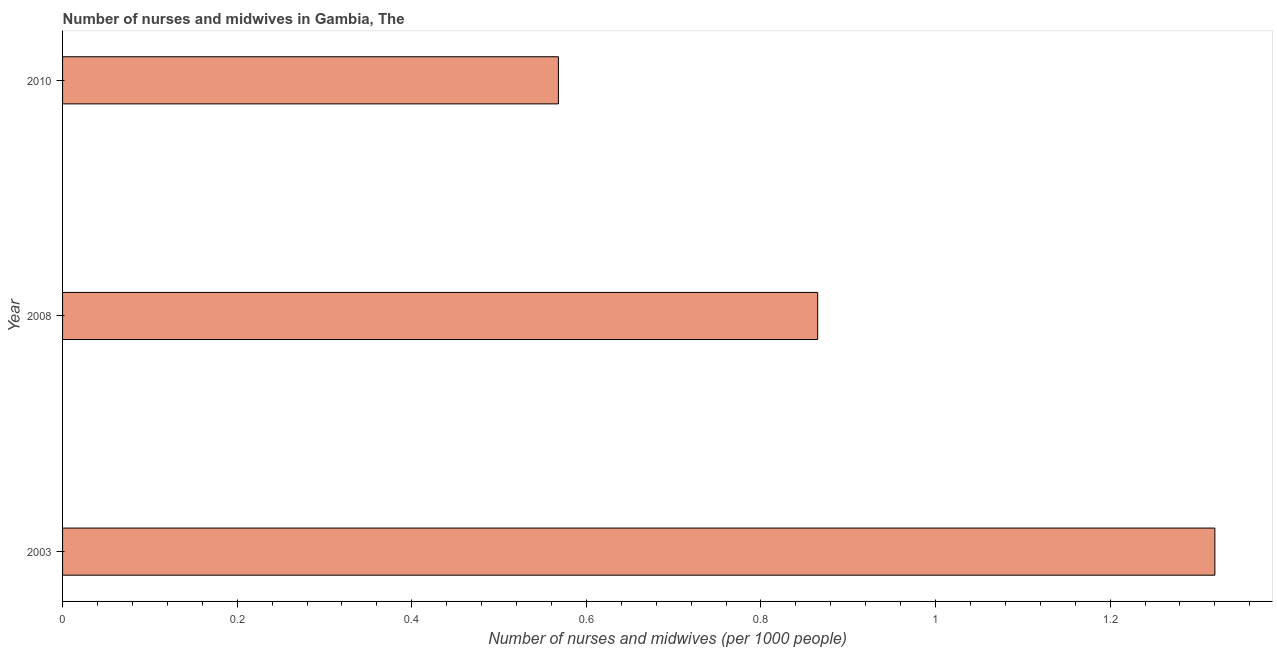What is the title of the graph?
Give a very brief answer. Number of nurses and midwives in Gambia, The. What is the label or title of the X-axis?
Provide a succinct answer. Number of nurses and midwives (per 1000 people). What is the label or title of the Y-axis?
Make the answer very short. Year. What is the number of nurses and midwives in 2008?
Ensure brevity in your answer.  0.86. Across all years, what is the maximum number of nurses and midwives?
Your answer should be very brief. 1.32. Across all years, what is the minimum number of nurses and midwives?
Your response must be concise. 0.57. In which year was the number of nurses and midwives maximum?
Your response must be concise. 2003. What is the sum of the number of nurses and midwives?
Provide a succinct answer. 2.75. What is the difference between the number of nurses and midwives in 2003 and 2010?
Your answer should be very brief. 0.75. What is the average number of nurses and midwives per year?
Ensure brevity in your answer.  0.92. What is the median number of nurses and midwives?
Give a very brief answer. 0.86. In how many years, is the number of nurses and midwives greater than 0.84 ?
Provide a short and direct response. 2. Do a majority of the years between 2008 and 2010 (inclusive) have number of nurses and midwives greater than 0.44 ?
Provide a short and direct response. Yes. What is the ratio of the number of nurses and midwives in 2008 to that in 2010?
Provide a short and direct response. 1.52. Is the difference between the number of nurses and midwives in 2003 and 2010 greater than the difference between any two years?
Your answer should be compact. Yes. What is the difference between the highest and the second highest number of nurses and midwives?
Ensure brevity in your answer.  0.46. In how many years, is the number of nurses and midwives greater than the average number of nurses and midwives taken over all years?
Make the answer very short. 1. How many bars are there?
Provide a succinct answer. 3. Are the values on the major ticks of X-axis written in scientific E-notation?
Offer a terse response. No. What is the Number of nurses and midwives (per 1000 people) in 2003?
Offer a very short reply. 1.32. What is the Number of nurses and midwives (per 1000 people) in 2008?
Your answer should be compact. 0.86. What is the Number of nurses and midwives (per 1000 people) of 2010?
Provide a succinct answer. 0.57. What is the difference between the Number of nurses and midwives (per 1000 people) in 2003 and 2008?
Your answer should be very brief. 0.46. What is the difference between the Number of nurses and midwives (per 1000 people) in 2003 and 2010?
Your answer should be compact. 0.75. What is the difference between the Number of nurses and midwives (per 1000 people) in 2008 and 2010?
Give a very brief answer. 0.3. What is the ratio of the Number of nurses and midwives (per 1000 people) in 2003 to that in 2008?
Give a very brief answer. 1.53. What is the ratio of the Number of nurses and midwives (per 1000 people) in 2003 to that in 2010?
Keep it short and to the point. 2.32. What is the ratio of the Number of nurses and midwives (per 1000 people) in 2008 to that in 2010?
Your answer should be compact. 1.52. 